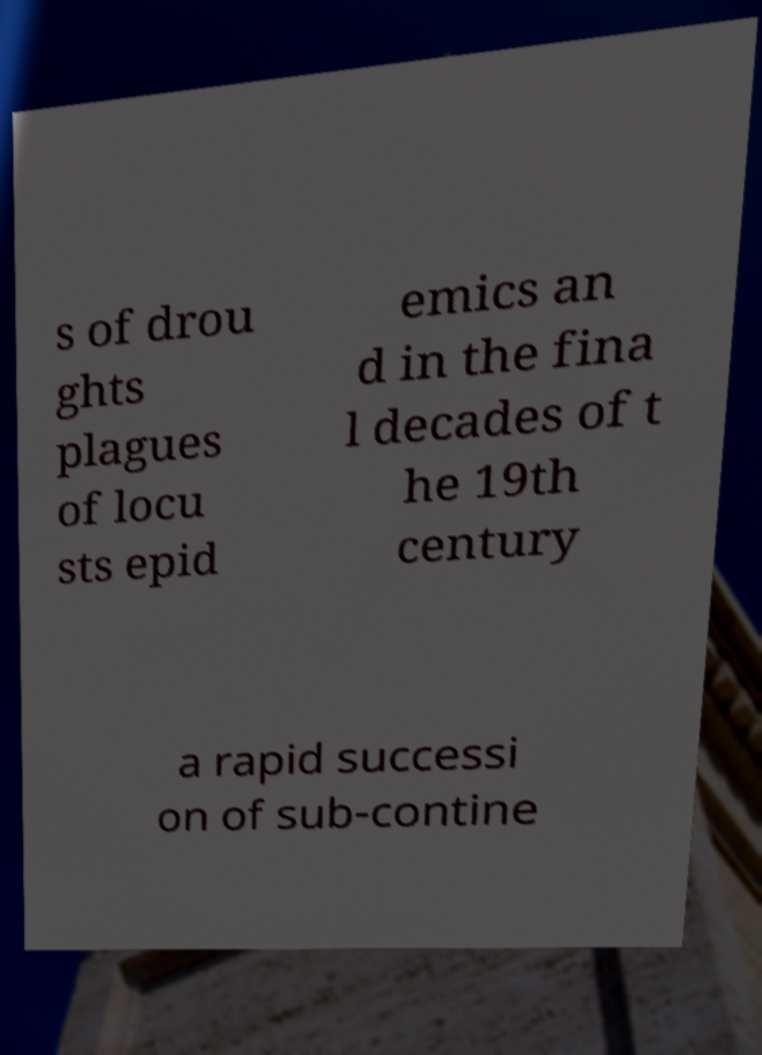What messages or text are displayed in this image? I need them in a readable, typed format. s of drou ghts plagues of locu sts epid emics an d in the fina l decades of t he 19th century a rapid successi on of sub-contine 